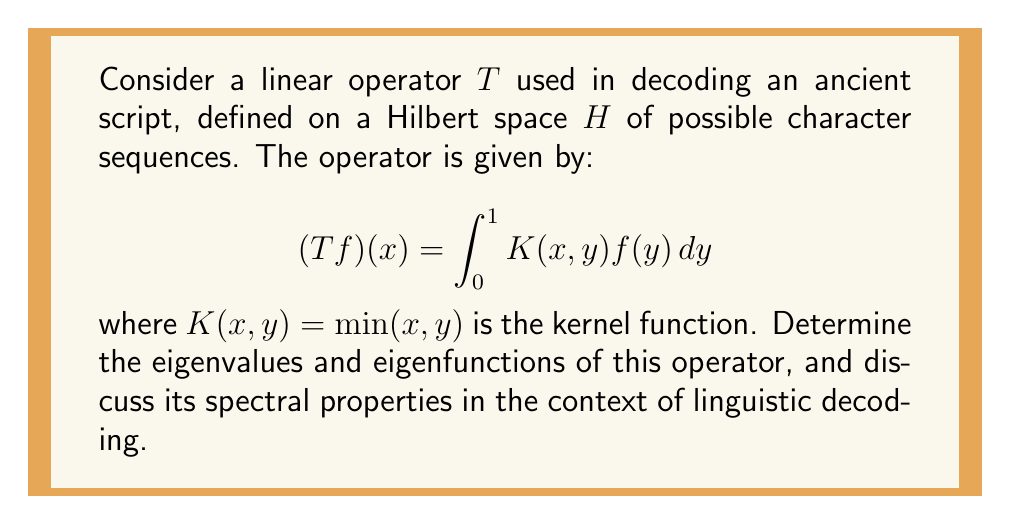Give your solution to this math problem. To solve this problem, we'll follow these steps:

1) First, we need to set up and solve the eigenvalue equation:
   $$Tf = \lambda f$$

2) Substituting the definition of $T$, we get:
   $$\int_0^1 \min(x,y)f(y)dy = \lambda f(x)$$

3) Differentiating both sides with respect to $x$:
   $$\int_0^x f(y)dy = \lambda f'(x)$$

4) Differentiating again:
   $$f(x) = \lambda f''(x)$$

5) This is a second-order differential equation. The general solution is:
   $$f(x) = A\sin(\frac{x}{\sqrt{\lambda}}) + B\cos(\frac{x}{\sqrt{\lambda}})$$

6) Applying the boundary conditions:
   At $x=0$: $f(0) = 0$ implies $B = 0$
   At $x=1$: $f'(1) = 0$ implies $\cos(\frac{1}{\sqrt{\lambda}}) = 0$

7) The second condition gives us the eigenvalues:
   $$\frac{1}{\sqrt{\lambda_n}} = \frac{\pi}{2} + n\pi, \quad n = 0, 1, 2, ...$$
   $$\lambda_n = \frac{4}{(2n+1)^2\pi^2}$$

8) The corresponding eigenfunctions are:
   $$f_n(x) = \sin(\frac{(2n+1)\pi x}{2})$$

In the context of linguistic decoding, these spectral properties have several implications:

1) The operator is compact, as it has a discrete spectrum that converges to zero.
2) The eigenvalues decay quadratically, indicating a smooth averaging effect of the operator.
3) The eigenfunctions form an orthonormal basis of $H$, allowing any character sequence to be decomposed into these components.
4) The decay rate of eigenvalues suggests how much information is preserved in each spectral component, which could inform the prioritization of features in the decoding process.
Answer: The eigenvalues are $\lambda_n = \frac{4}{(2n+1)^2\pi^2}$ for $n = 0, 1, 2, ...$, and the corresponding eigenfunctions are $f_n(x) = \sin(\frac{(2n+1)\pi x}{2})$. The operator is compact with a discrete spectrum converging to zero, indicating a smooth averaging effect in linguistic decoding. 